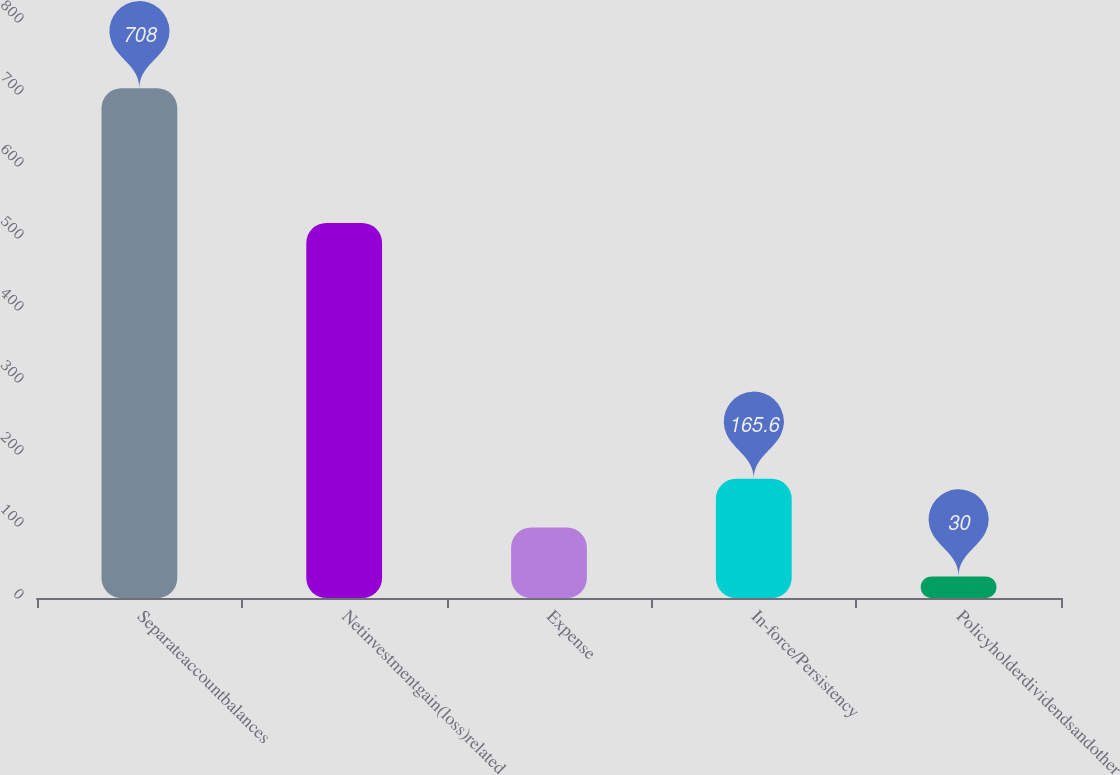Convert chart to OTSL. <chart><loc_0><loc_0><loc_500><loc_500><bar_chart><fcel>Separateaccountbalances<fcel>Netinvestmentgain(loss)related<fcel>Expense<fcel>In-force/Persistency<fcel>Policyholderdividendsandother<nl><fcel>708<fcel>521<fcel>97.8<fcel>165.6<fcel>30<nl></chart> 